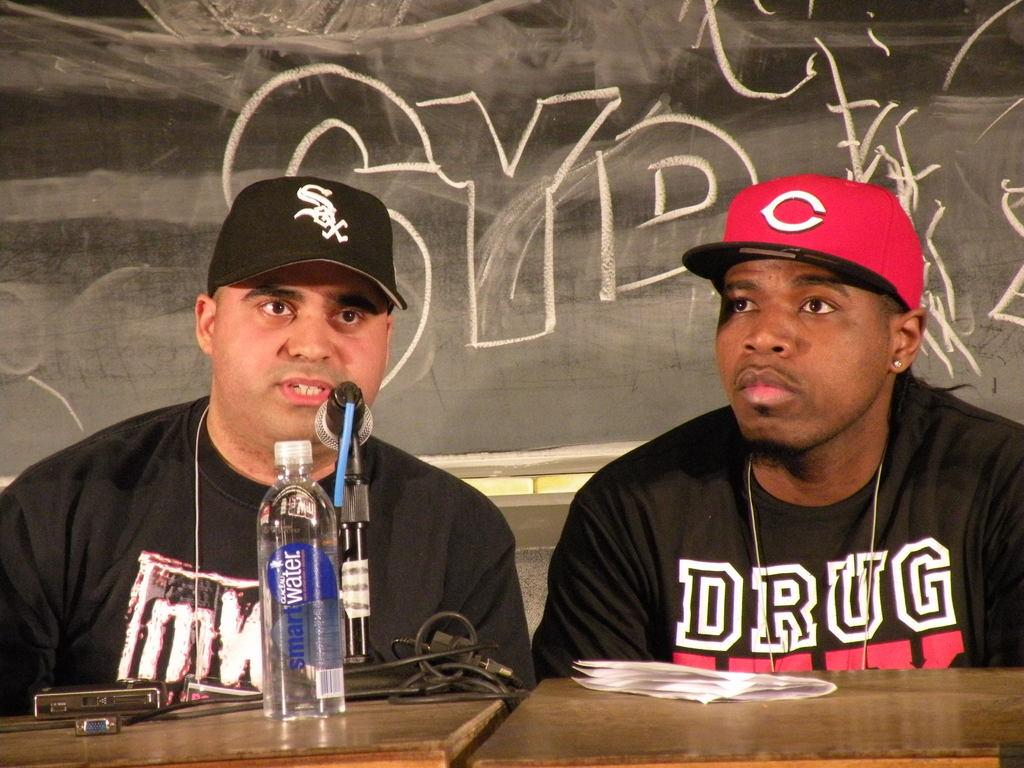<image>
Present a compact description of the photo's key features. A bottle of smart water is on the desk in front of two people at a microphone. 